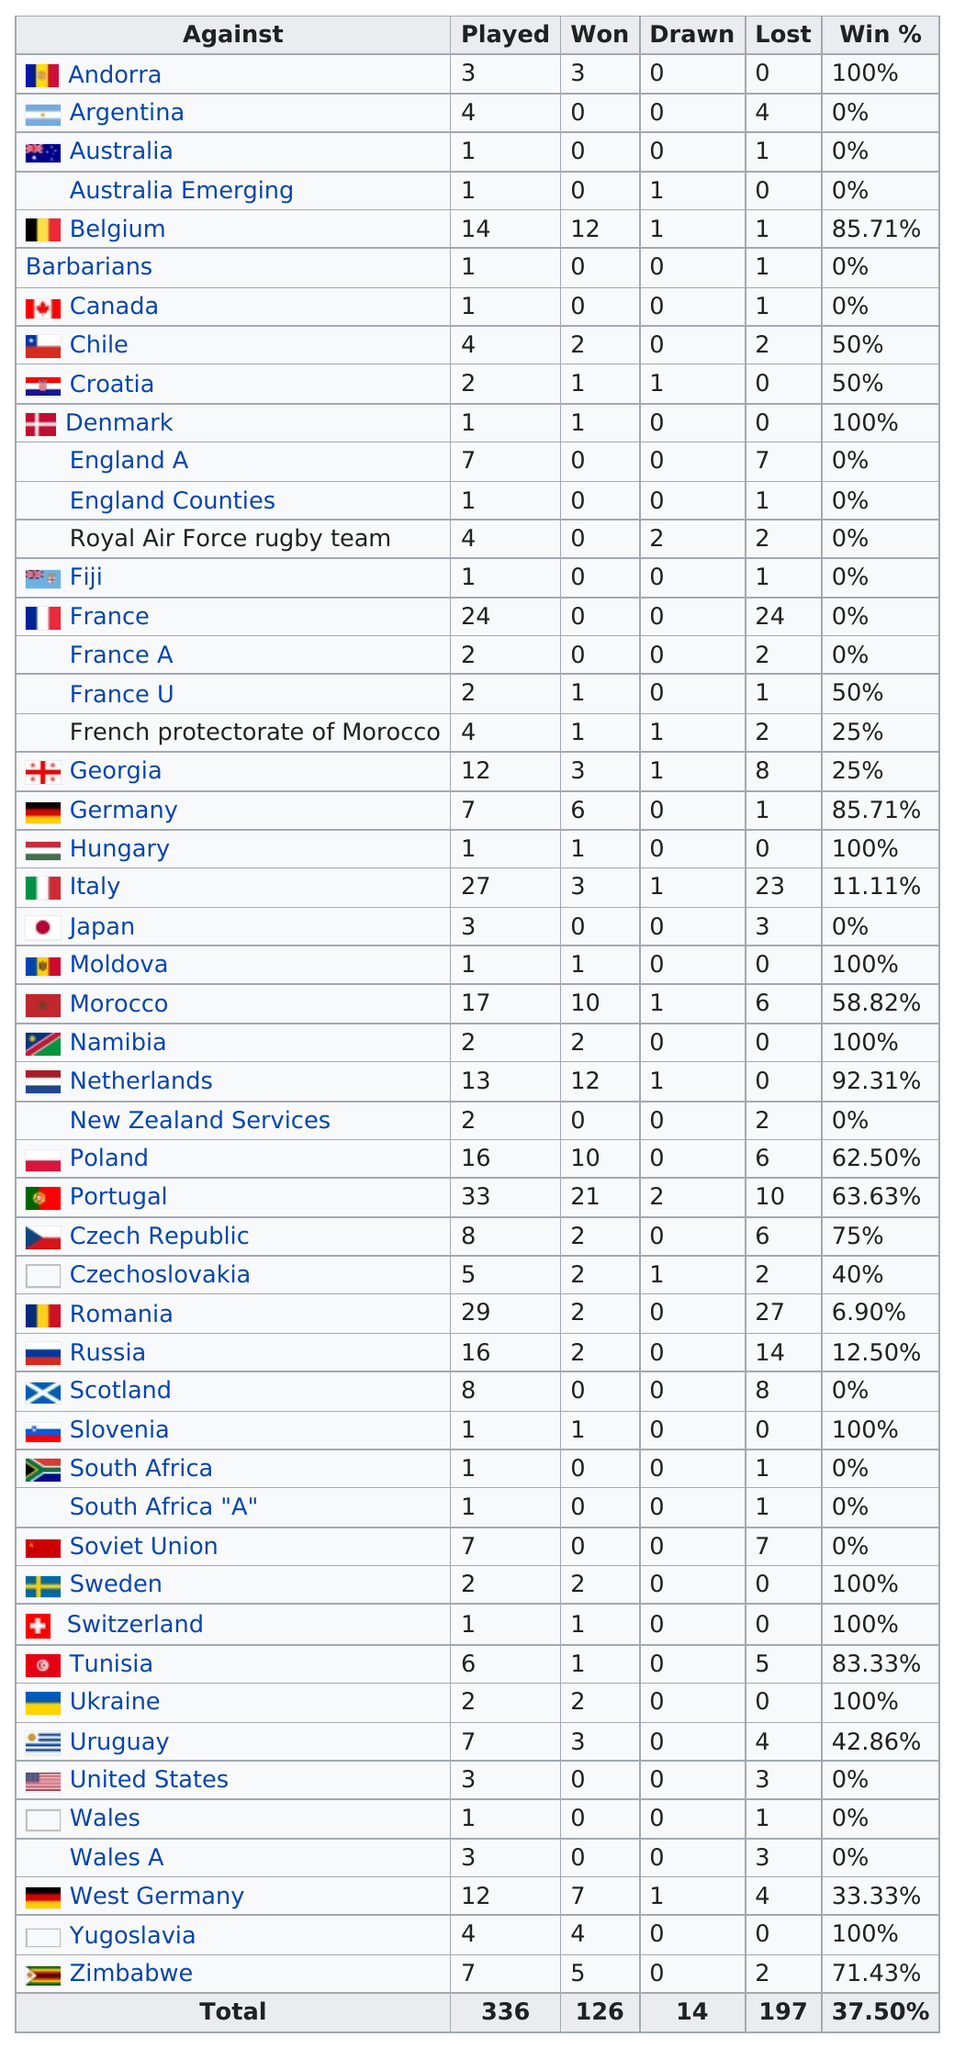Point out several critical features in this image. Portugal has won the most games out of all countries. It is clear that Portugal is the country that has been opposing them the most. Seven countries have played more than 15 games. According to data, Spain has achieved at least a 100% win percentage against another country. Spain has yet to defeat or draw with Australia, a country that is emerging as a formidable opponent. 